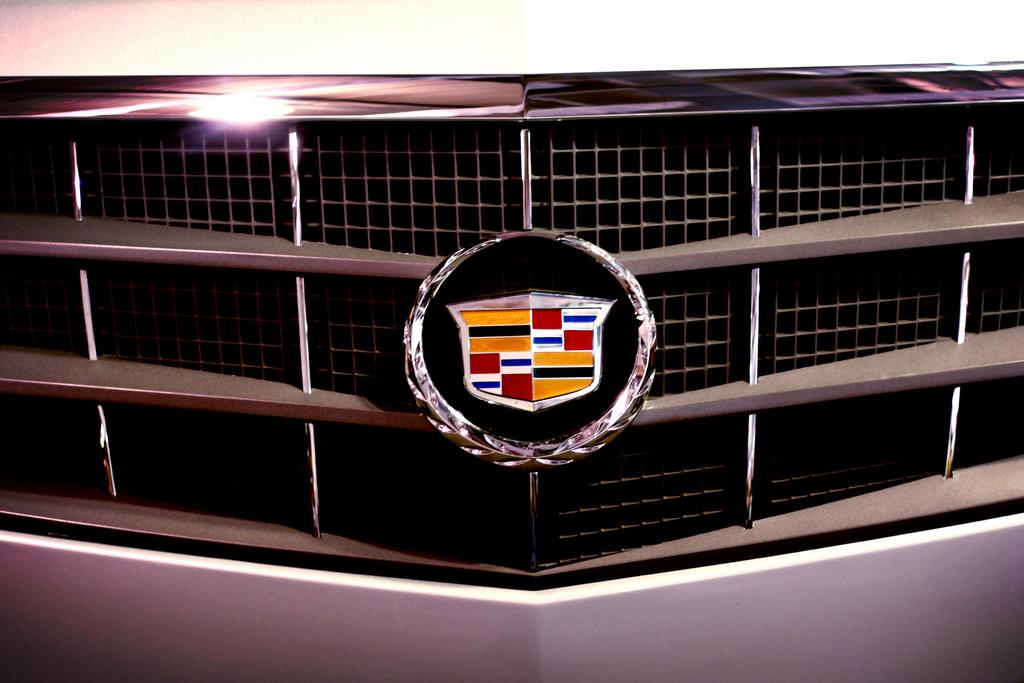What part of a vehicle is shown in the image? The image shows the front part of a vehicle. What can be seen in the middle of the vehicle? There is a logo visible in the middle of the vehicle. What type of rock is being used to support the vehicle in the image? There is no rock present in the image; the vehicle is not supported by any rock. 